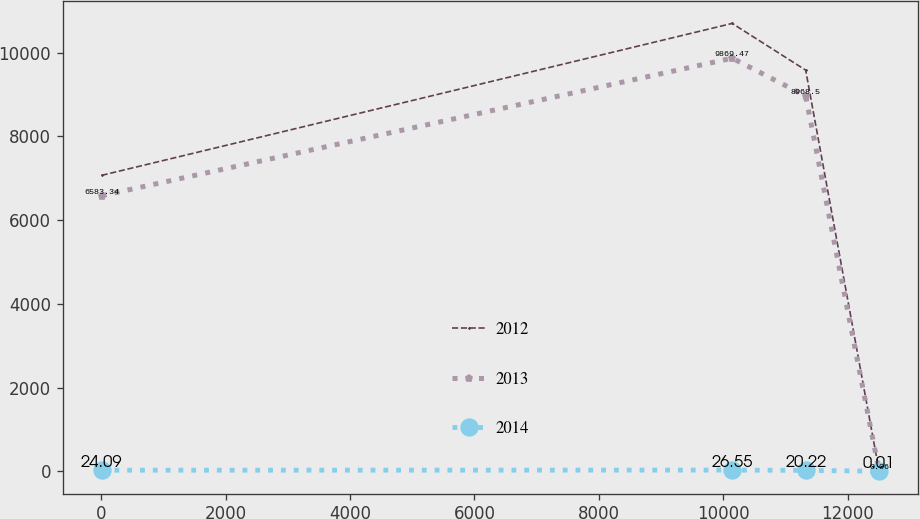Convert chart to OTSL. <chart><loc_0><loc_0><loc_500><loc_500><line_chart><ecel><fcel>2012<fcel>2013<fcel>2014<nl><fcel>5.93<fcel>7069.76<fcel>6583.34<fcel>24.09<nl><fcel>10145.4<fcel>10700.5<fcel>9869.47<fcel>26.55<nl><fcel>11326.6<fcel>9584.16<fcel>8968.5<fcel>20.22<nl><fcel>12507.7<fcel>0<fcel>0.06<fcel>0.01<nl></chart> 